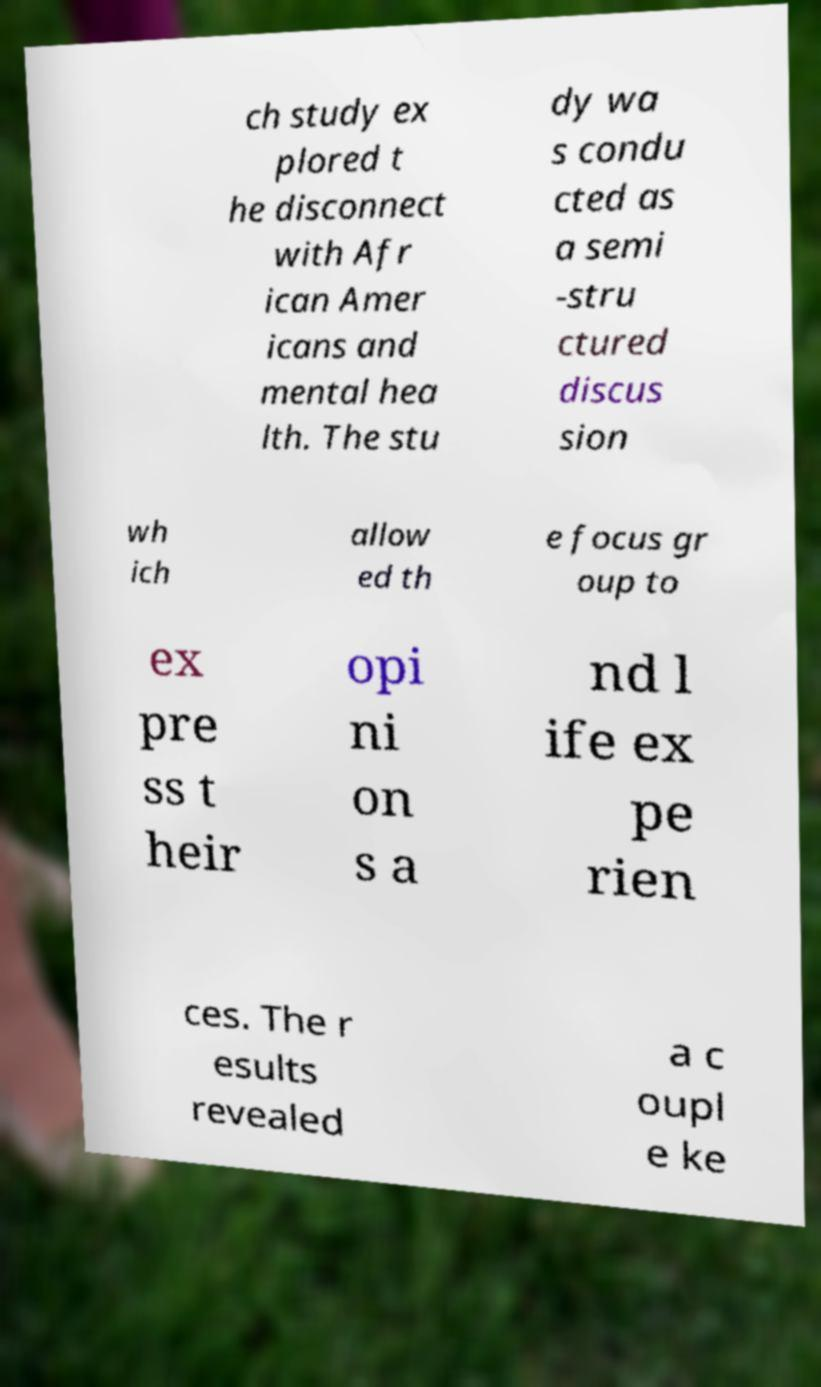I need the written content from this picture converted into text. Can you do that? ch study ex plored t he disconnect with Afr ican Amer icans and mental hea lth. The stu dy wa s condu cted as a semi -stru ctured discus sion wh ich allow ed th e focus gr oup to ex pre ss t heir opi ni on s a nd l ife ex pe rien ces. The r esults revealed a c oupl e ke 